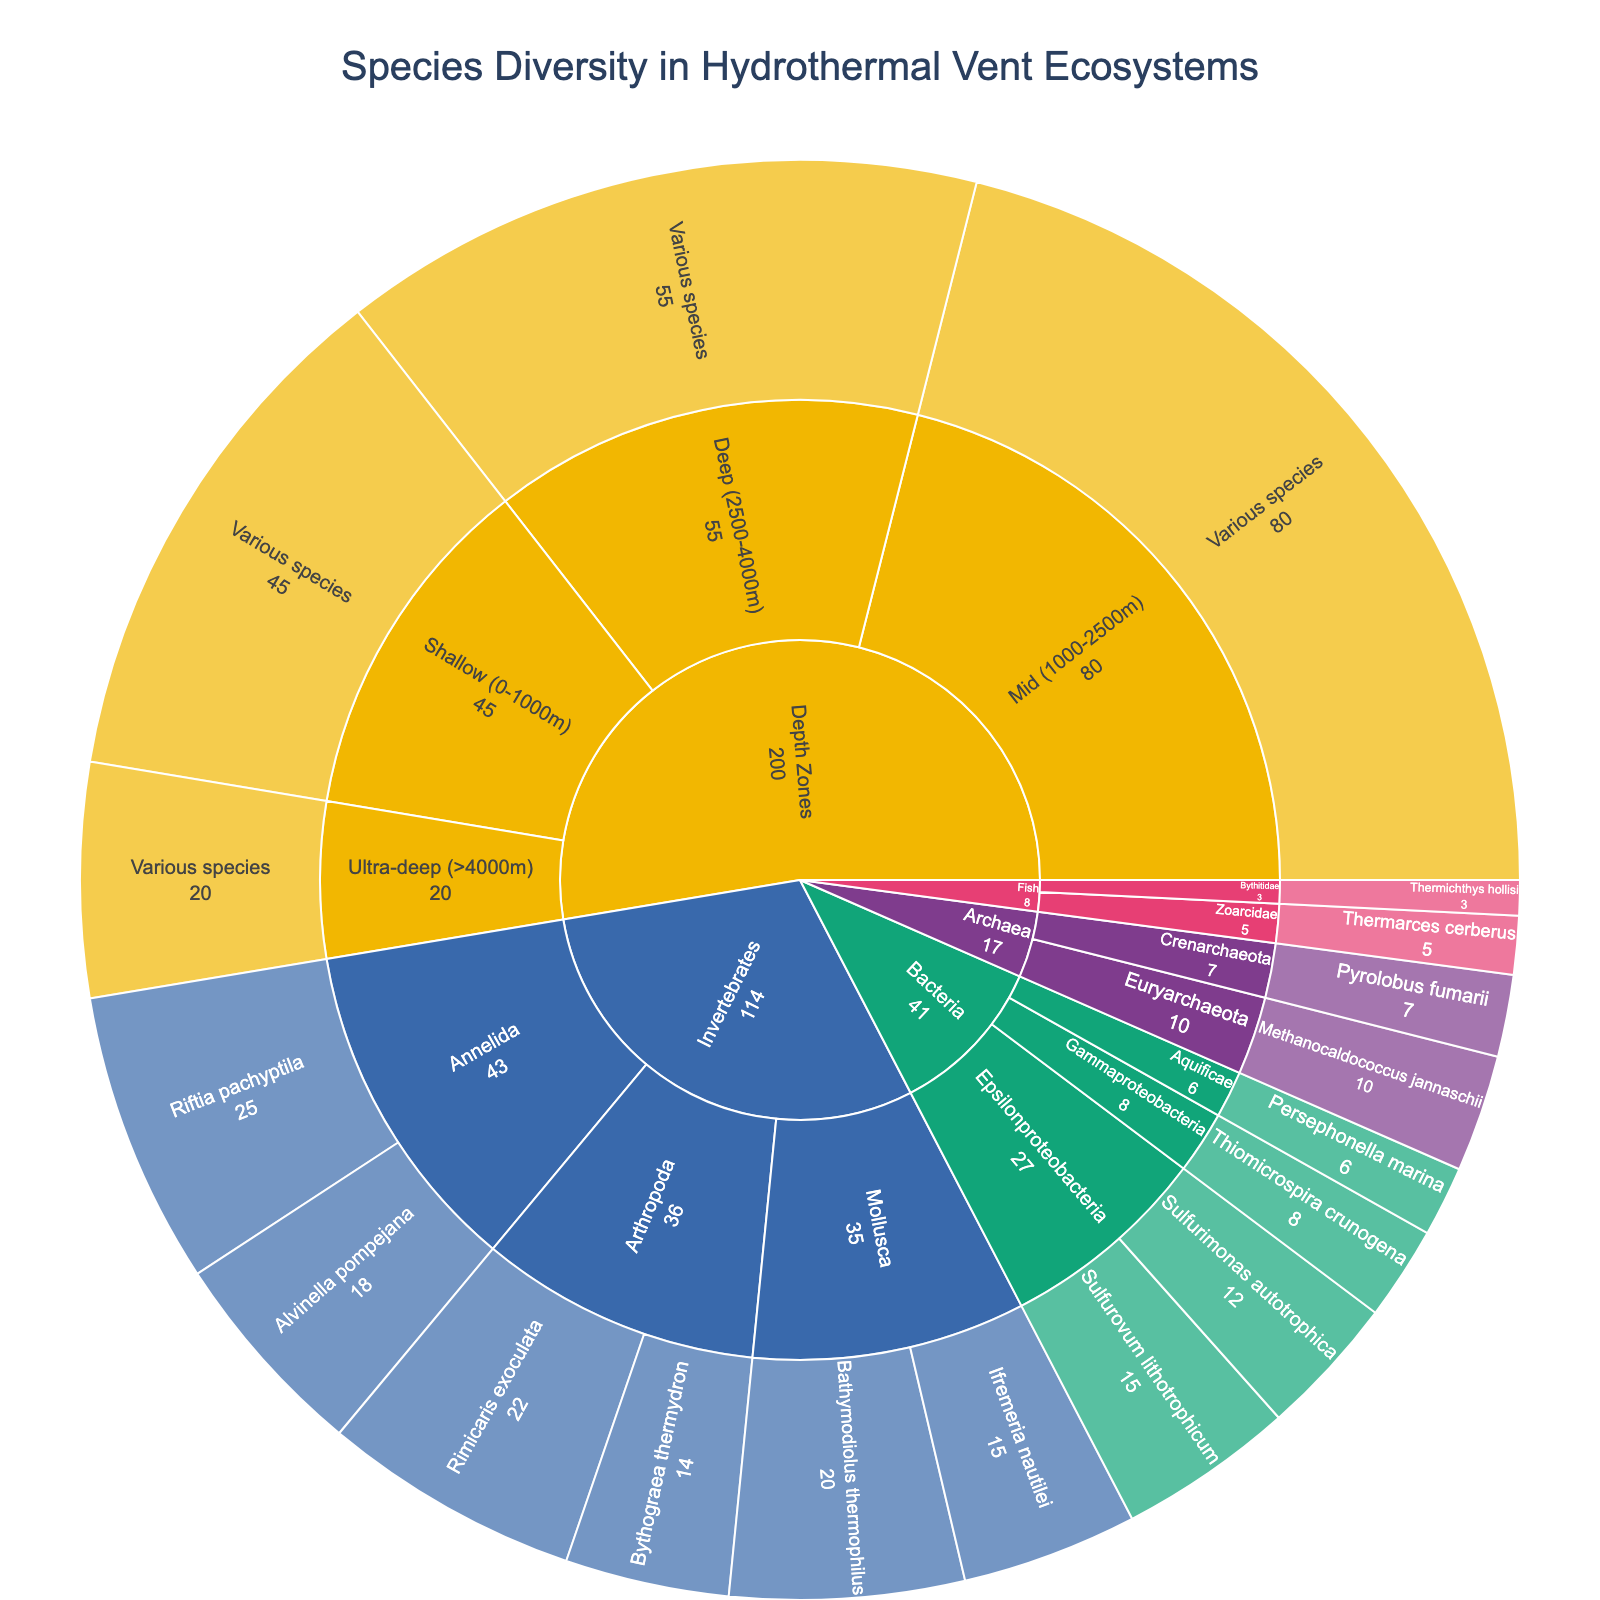what is the title of the figure? The title is usually located at the top of the figure. The title of this sunburst plot is "Species Diversity in Hydrothermal Vent Ecosystems"
Answer: Species Diversity in Hydrothermal Vent Ecosystems How many species of Epsilonproteobacteria are shown in the plot? Identify the subcategory Epsilonproteobacteria, then count the species within this subcategory. There are two species: Sulfurovum lithotrophicum and Sulfurimonas autotrophica.
Answer: 2 Which taxonomic group has the highest individual species value and what is that value? Examine the values associated with each species across all taxonomic groups. Riftia pachyptila under the Annelida subcategory has the highest value, which is 25.
Answer: Riftia pachyptila, 25 What is the total value of species in the Arthropoda subcategory? Add the values of each species in the Arthropoda subcategory: Rimicaris exoculata (22) and Bythograea thermydron (14). The total is 22 + 14 = 36.
Answer: 36 Compare the total values for the subcategories Euryarchaeota and Crenarchaeota under Archaea. Which one is larger and by how much? Sum the values for each subcategory: Euryarchaeota (Methanocaldococcus jannaschii = 10) and Crenarchaeota (Pyrolobus fumarii = 7). Euryarchaeota has 10, Crenarchaeota has 7. The difference is 10 - 7 = 3.
Answer: Euryarchaeota, 3 What proportion of the total value is occupied by the 'Deep (2500-4000m)' depth zone? Sum the total value for all depth zones: Shallow (45) + Mid (80) + Deep (55) + Ultra-deep (20) = 200. The proportion for Deep is 55/200 = 0.275.
Answer: 27.5% Which fish species has a lower value, Thermarces cerberus or Thermichthys hollisi? Compare the values of the two fish species: Thermarces cerberus (5) and Thermichthys hollisi (3). The one with the lower value is Thermichthys hollisi.
Answer: Thermichthys hollisi What is the average value of species in the Gammaproteobacteria and Aquificae subcategories? Calculate the average of the values of species in Gammaproteobacteria (Thiomicrospira crunogena = 8) and Aquificae (Persephonella marina = 6). The average is (8 + 6)/2 = 7.
Answer: 7 In which depth zone is species diversity the highest, and how can you tell? Compare the values associated with various species across the depth zones. The Mid (1000-2500m) depth zone has the highest value at 80, indicating the highest species diversity.
Answer: Mid (1000-2500m) What is the relationship between the values for Mollusca and Annelida within the Invertebrates category? Compare the sum of values for Mollusca (Bathymodiolus thermophilus = 20, Ifremeria nautilei = 15, total 35) and Annelida (Riftia pachyptila = 25, Alvinella pompejana = 18, total 43). Annelida has a higher total value.
Answer: Annelida has a higher total value than Mollusca 